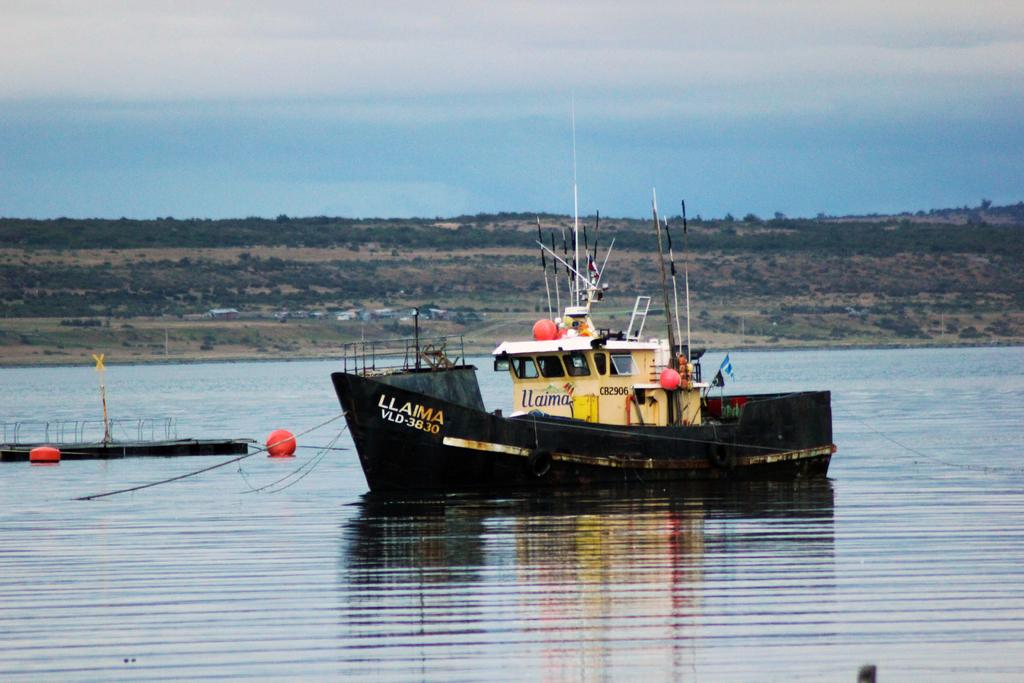What is the main subject of the image? The main subject of the image is a ship. What can be seen above the water in the image? There are red objects above the water in the image. What type of natural environment is visible in the background of the image? There are trees visible in the background of the image. What is visible in the sky in the background of the image? The sky is visible in the background of the image. Can you tell me how many times the wool jumps in the image? There is no wool or jumping activity present in the image. What type of bone can be seen sticking out of the ship in the image? There is no bone present in the image; it features a ship and red objects above the water. 